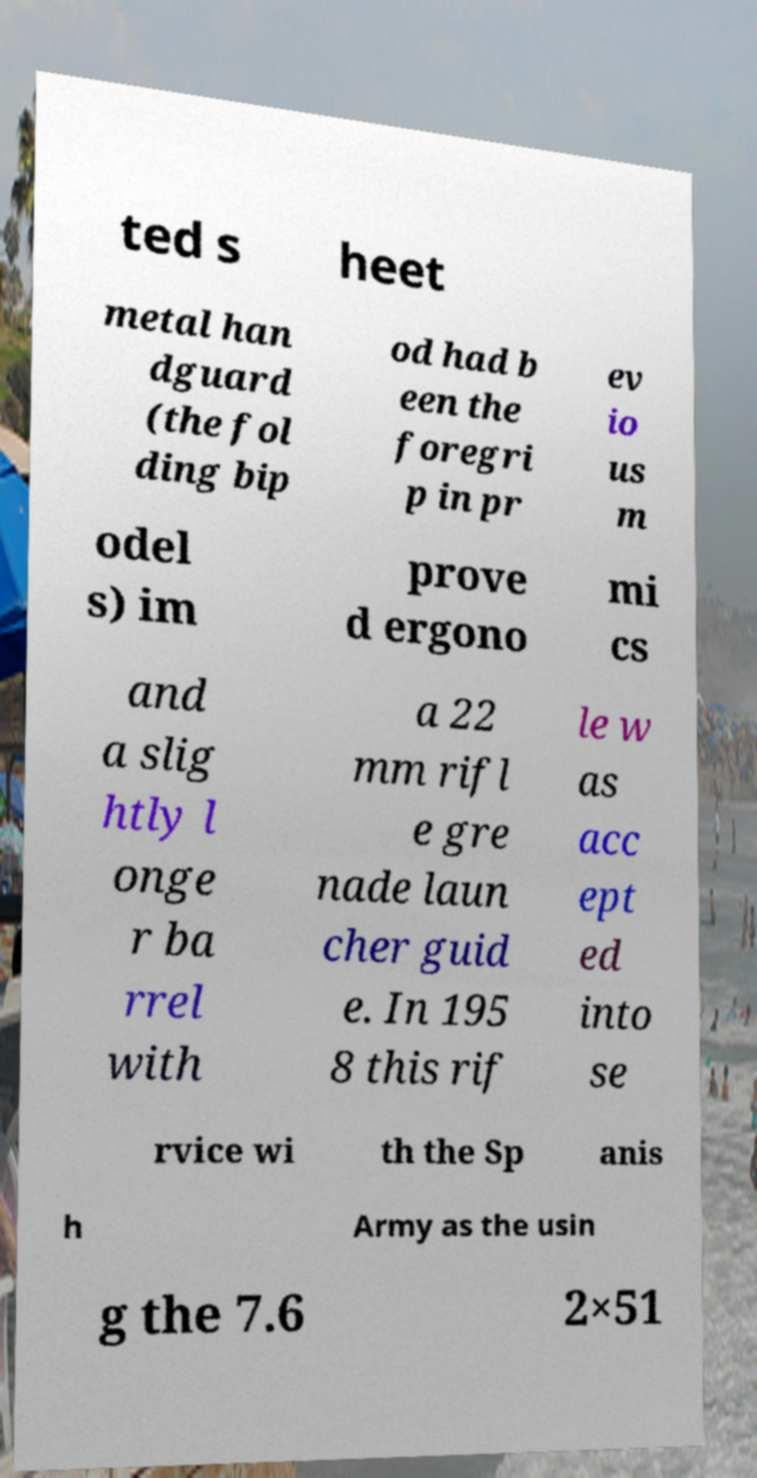Can you accurately transcribe the text from the provided image for me? ted s heet metal han dguard (the fol ding bip od had b een the foregri p in pr ev io us m odel s) im prove d ergono mi cs and a slig htly l onge r ba rrel with a 22 mm rifl e gre nade laun cher guid e. In 195 8 this rif le w as acc ept ed into se rvice wi th the Sp anis h Army as the usin g the 7.6 2×51 